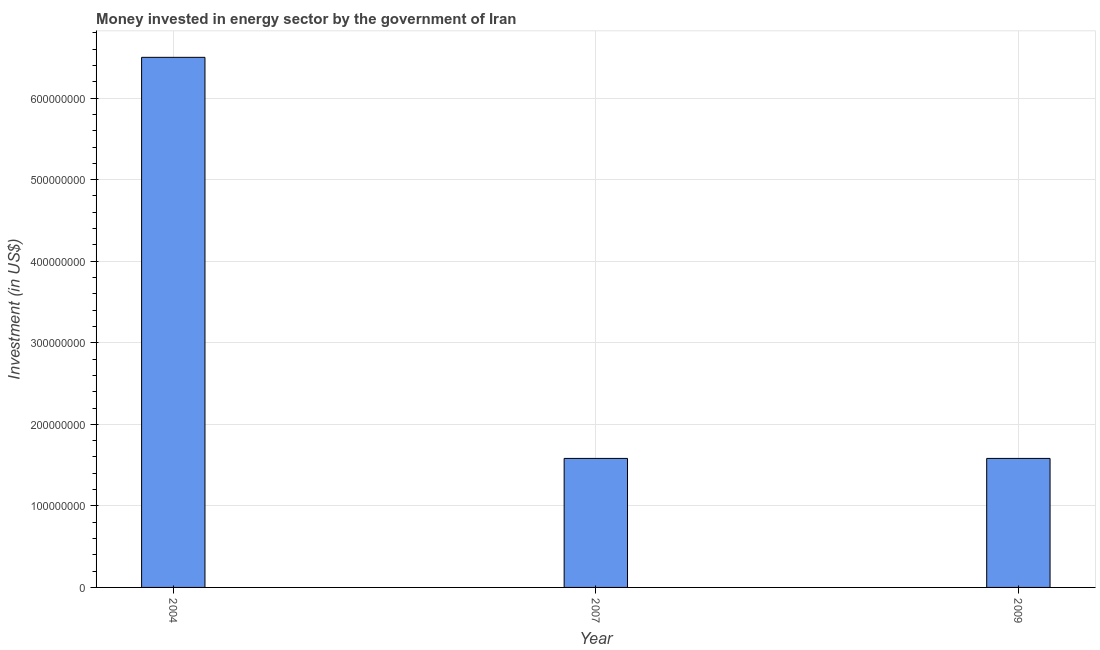Does the graph contain any zero values?
Provide a short and direct response. No. What is the title of the graph?
Your answer should be compact. Money invested in energy sector by the government of Iran. What is the label or title of the X-axis?
Ensure brevity in your answer.  Year. What is the label or title of the Y-axis?
Your response must be concise. Investment (in US$). What is the investment in energy in 2009?
Make the answer very short. 1.58e+08. Across all years, what is the maximum investment in energy?
Keep it short and to the point. 6.50e+08. Across all years, what is the minimum investment in energy?
Provide a short and direct response. 1.58e+08. In which year was the investment in energy maximum?
Your response must be concise. 2004. In which year was the investment in energy minimum?
Provide a short and direct response. 2007. What is the sum of the investment in energy?
Offer a very short reply. 9.66e+08. What is the difference between the investment in energy in 2004 and 2007?
Give a very brief answer. 4.92e+08. What is the average investment in energy per year?
Ensure brevity in your answer.  3.22e+08. What is the median investment in energy?
Offer a terse response. 1.58e+08. In how many years, is the investment in energy greater than 660000000 US$?
Your answer should be compact. 0. What is the ratio of the investment in energy in 2007 to that in 2009?
Ensure brevity in your answer.  1. Is the investment in energy in 2004 less than that in 2009?
Keep it short and to the point. No. Is the difference between the investment in energy in 2004 and 2007 greater than the difference between any two years?
Offer a very short reply. Yes. What is the difference between the highest and the second highest investment in energy?
Ensure brevity in your answer.  4.92e+08. What is the difference between the highest and the lowest investment in energy?
Keep it short and to the point. 4.92e+08. How many bars are there?
Keep it short and to the point. 3. Are all the bars in the graph horizontal?
Provide a short and direct response. No. What is the Investment (in US$) of 2004?
Your answer should be compact. 6.50e+08. What is the Investment (in US$) of 2007?
Give a very brief answer. 1.58e+08. What is the Investment (in US$) of 2009?
Provide a short and direct response. 1.58e+08. What is the difference between the Investment (in US$) in 2004 and 2007?
Provide a short and direct response. 4.92e+08. What is the difference between the Investment (in US$) in 2004 and 2009?
Give a very brief answer. 4.92e+08. What is the ratio of the Investment (in US$) in 2004 to that in 2007?
Keep it short and to the point. 4.11. What is the ratio of the Investment (in US$) in 2004 to that in 2009?
Your answer should be very brief. 4.11. 